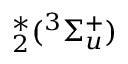Convert formula to latex. <formula><loc_0><loc_0><loc_500><loc_500>^ { * } _ { 2 } ( ^ { 3 } \Sigma _ { u } ^ { + } )</formula> 